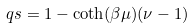Convert formula to latex. <formula><loc_0><loc_0><loc_500><loc_500>\ q s = 1 - \coth ( \beta \mu ) ( \nu - 1 )</formula> 